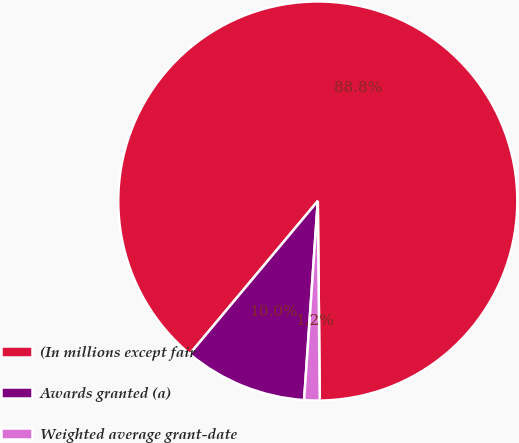Convert chart to OTSL. <chart><loc_0><loc_0><loc_500><loc_500><pie_chart><fcel>(In millions except fair<fcel>Awards granted (a)<fcel>Weighted average grant-date<nl><fcel>88.75%<fcel>10.0%<fcel>1.25%<nl></chart> 